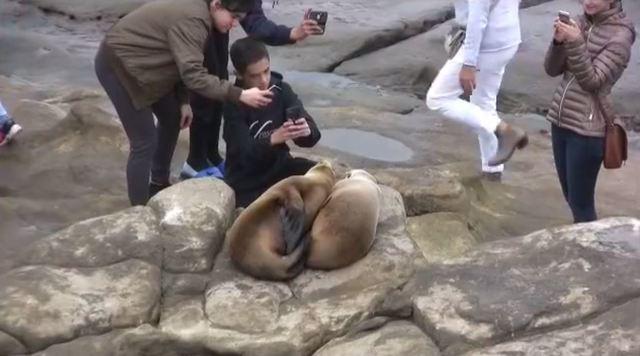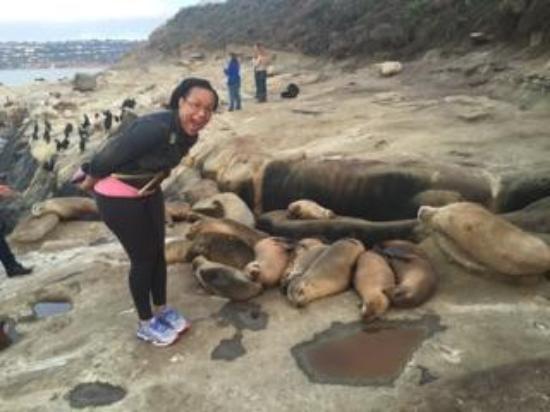The first image is the image on the left, the second image is the image on the right. For the images shown, is this caption "There are two sea lions in one of the images." true? Answer yes or no. Yes. 